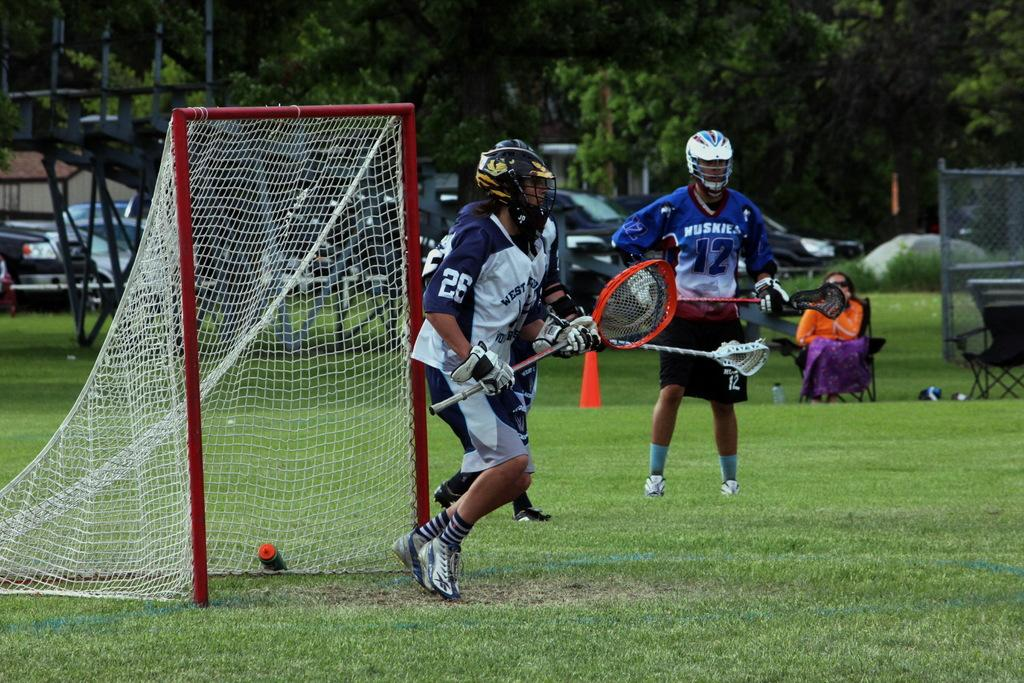<image>
Give a short and clear explanation of the subsequent image. The Huskies were prepared to assist the goal but West was ready as well. 